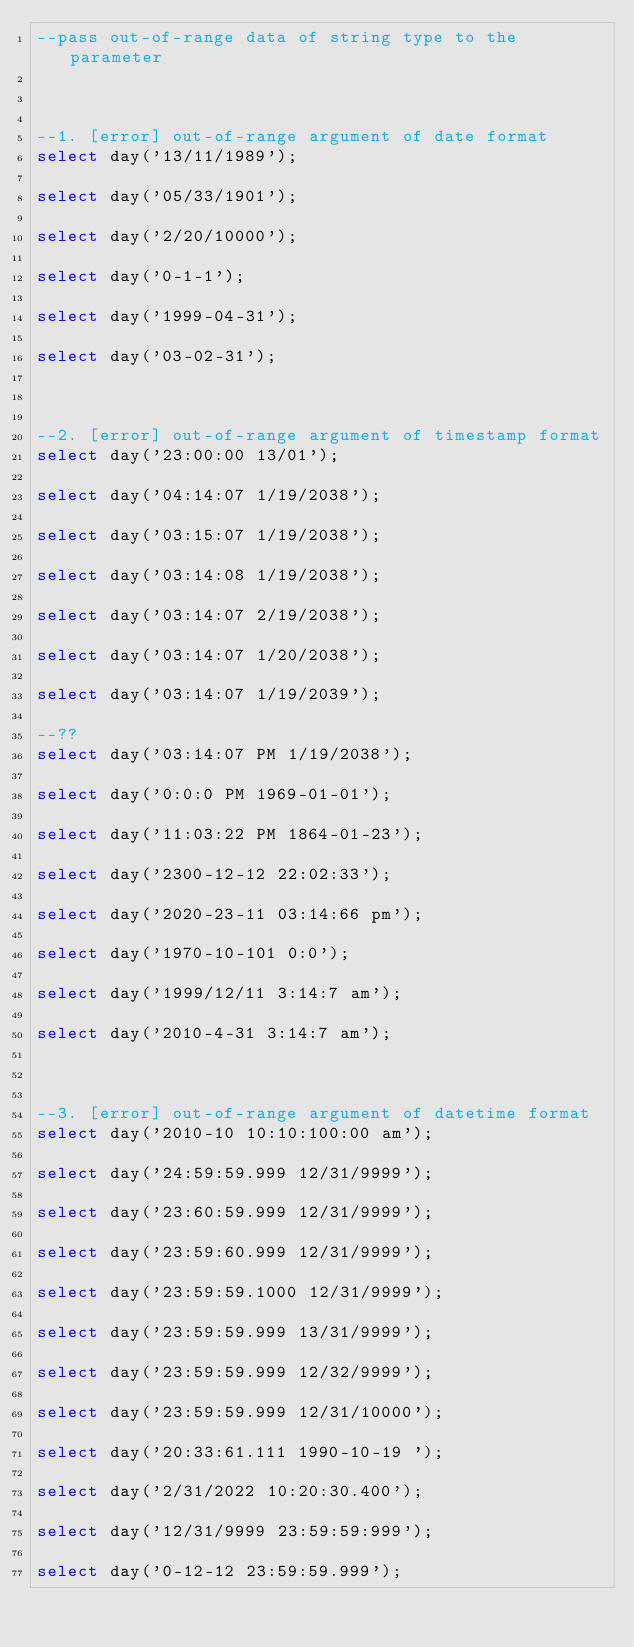<code> <loc_0><loc_0><loc_500><loc_500><_SQL_>--pass out-of-range data of string type to the parameter



--1. [error] out-of-range argument of date format
select day('13/11/1989');

select day('05/33/1901');

select day('2/20/10000');

select day('0-1-1');

select day('1999-04-31');

select day('03-02-31');



--2. [error] out-of-range argument of timestamp format
select day('23:00:00 13/01');

select day('04:14:07 1/19/2038');

select day('03:15:07 1/19/2038');

select day('03:14:08 1/19/2038');

select day('03:14:07 2/19/2038');

select day('03:14:07 1/20/2038');

select day('03:14:07 1/19/2039');

--??
select day('03:14:07 PM 1/19/2038');

select day('0:0:0 PM 1969-01-01');

select day('11:03:22 PM 1864-01-23');

select day('2300-12-12 22:02:33');

select day('2020-23-11 03:14:66 pm');

select day('1970-10-101 0:0');

select day('1999/12/11 3:14:7 am');

select day('2010-4-31 3:14:7 am');



--3. [error] out-of-range argument of datetime format
select day('2010-10 10:10:100:00 am');

select day('24:59:59.999 12/31/9999');

select day('23:60:59.999 12/31/9999');

select day('23:59:60.999 12/31/9999');

select day('23:59:59.1000 12/31/9999');

select day('23:59:59.999 13/31/9999');

select day('23:59:59.999 12/32/9999');

select day('23:59:59.999 12/31/10000');

select day('20:33:61.111 1990-10-19 ');

select day('2/31/2022 10:20:30.400');

select day('12/31/9999 23:59:59:999');

select day('0-12-12 23:59:59.999');

</code> 